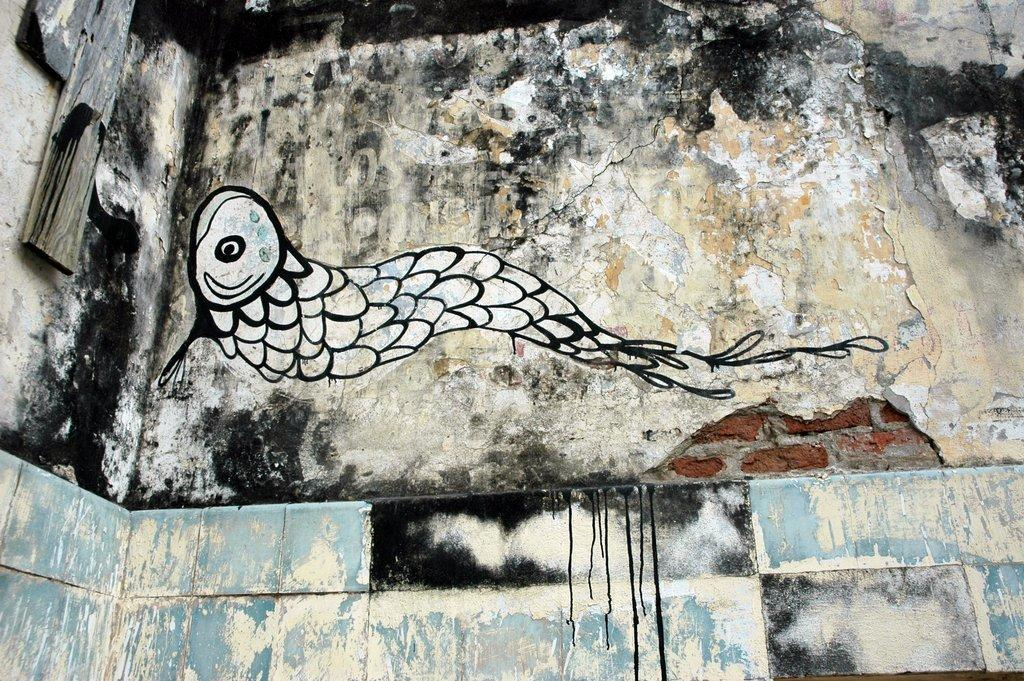What type of material is used to construct the wall in the image? The wall has tiles and bricks. Is there any artwork or decoration on the wall? Yes, there is a drawing on the wall. What can be seen on the right side of the wall? There are wooden pieces on the right side of the wall. What grade does the spot on the wall receive for its performance? There is no spot mentioned in the image, so it cannot be graded. 